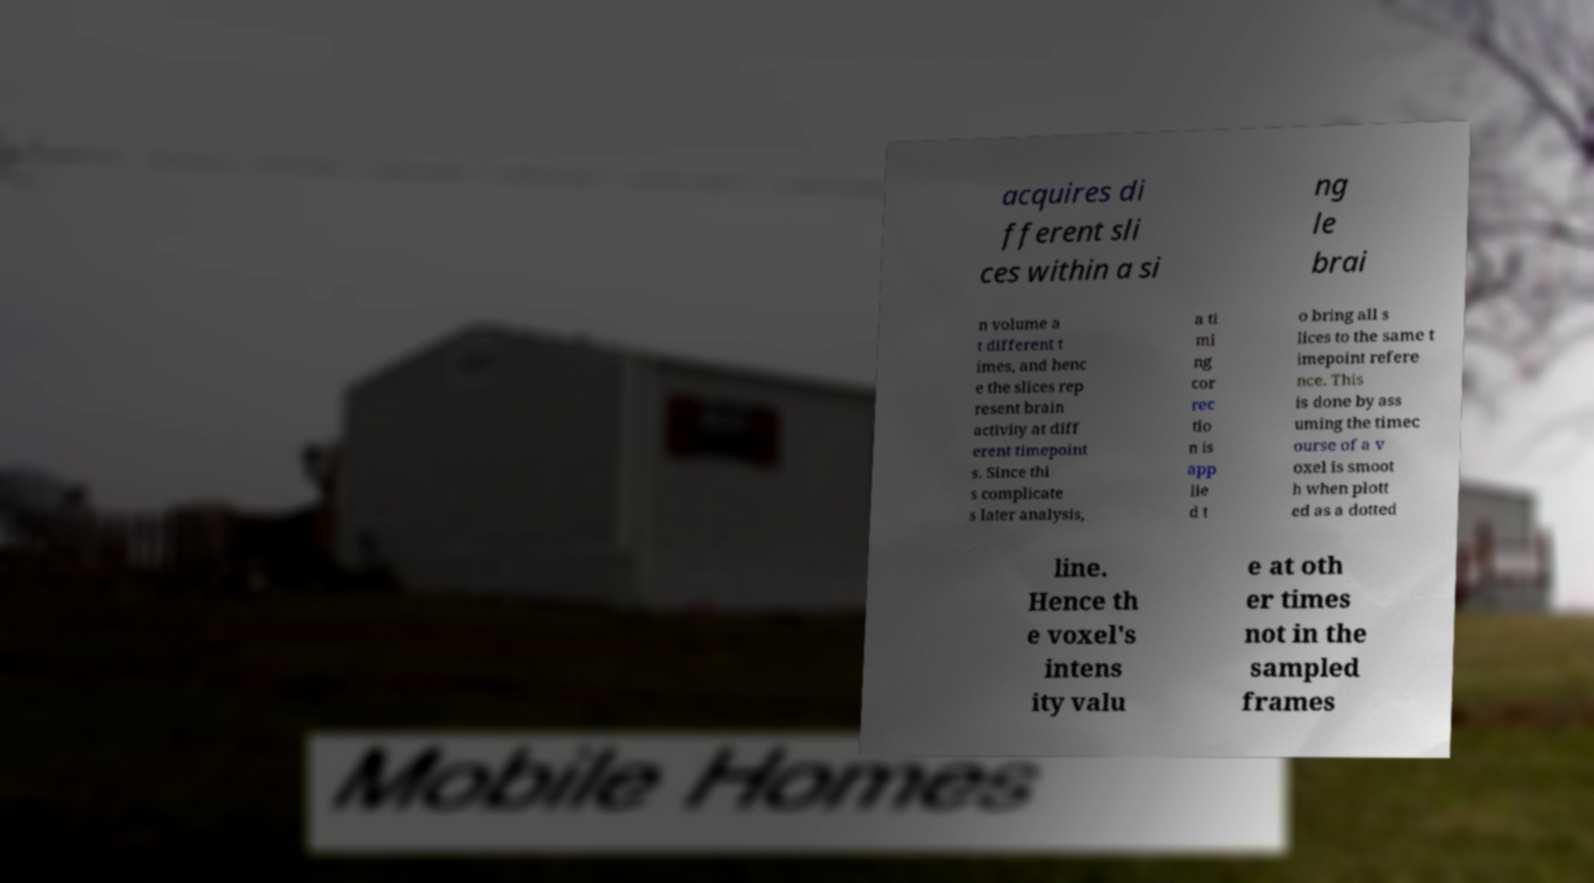I need the written content from this picture converted into text. Can you do that? acquires di fferent sli ces within a si ng le brai n volume a t different t imes, and henc e the slices rep resent brain activity at diff erent timepoint s. Since thi s complicate s later analysis, a ti mi ng cor rec tio n is app lie d t o bring all s lices to the same t imepoint refere nce. This is done by ass uming the timec ourse of a v oxel is smoot h when plott ed as a dotted line. Hence th e voxel's intens ity valu e at oth er times not in the sampled frames 